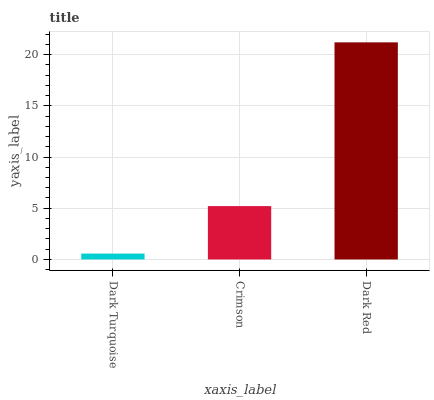Is Dark Turquoise the minimum?
Answer yes or no. Yes. Is Dark Red the maximum?
Answer yes or no. Yes. Is Crimson the minimum?
Answer yes or no. No. Is Crimson the maximum?
Answer yes or no. No. Is Crimson greater than Dark Turquoise?
Answer yes or no. Yes. Is Dark Turquoise less than Crimson?
Answer yes or no. Yes. Is Dark Turquoise greater than Crimson?
Answer yes or no. No. Is Crimson less than Dark Turquoise?
Answer yes or no. No. Is Crimson the high median?
Answer yes or no. Yes. Is Crimson the low median?
Answer yes or no. Yes. Is Dark Turquoise the high median?
Answer yes or no. No. Is Dark Red the low median?
Answer yes or no. No. 